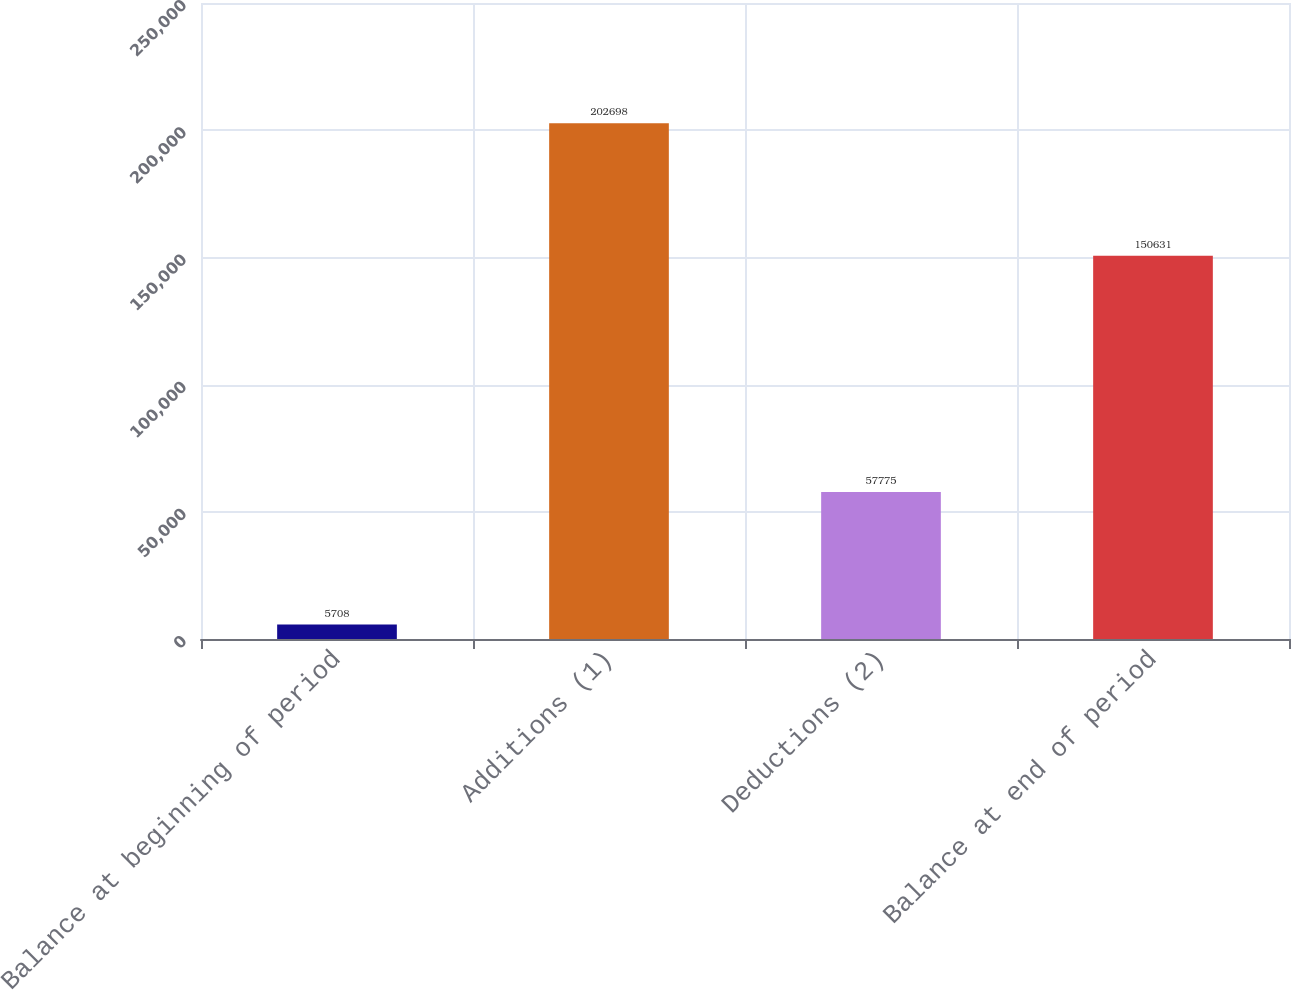Convert chart to OTSL. <chart><loc_0><loc_0><loc_500><loc_500><bar_chart><fcel>Balance at beginning of period<fcel>Additions (1)<fcel>Deductions (2)<fcel>Balance at end of period<nl><fcel>5708<fcel>202698<fcel>57775<fcel>150631<nl></chart> 